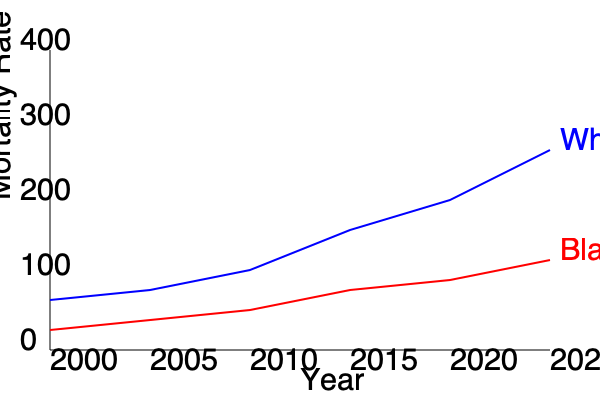Based on the graph showing mortality rates for White and Black populations from 2000 to 2025, what can be concluded about the trend in healthcare disparities between these two groups? How might this trend inform strategies to address healthcare inequities? To interpret the healthcare disparity trends from this multi-line graph and formulate strategies, we need to follow these steps:

1. Analyze the initial disparity:
   - In 2000, the mortality rate for the Black population (about 280 per 100,000) was significantly higher than for the White population (about 250 per 100,000).
   - This indicates a clear health disparity at the beginning of the period.

2. Examine the rate of change for each group:
   - The White population's mortality rate decreases more rapidly, from about 250 to 100 per 100,000 over the 25-year period.
   - The Black population's mortality rate decreases more slowly, from about 280 to 210 per 100,000.

3. Compare the slopes of the lines:
   - The steeper slope for the White population indicates faster improvement in health outcomes.
   - The gentler slope for the Black population suggests slower progress in reducing mortality rates.

4. Assess the gap between the two lines over time:
   - The gap between the two lines widens as time progresses, indicating an increasing disparity.
   - By 2025, the projected gap is larger than it was in 2000, despite overall improvements for both groups.

5. Calculate the relative disparity:
   - In 2000: (280 - 250) / 250 ≈ 12% higher mortality rate for Black population
   - In 2025: (210 - 100) / 100 = 110% higher mortality rate for Black population

6. Interpret the trend:
   - While both populations show improving health outcomes, the rate of improvement is unequal.
   - The disparity is actually worsening over time in relative terms, even as absolute mortality rates decrease for both groups.

7. Implications for healthcare strategies:
   - Need for targeted interventions to accelerate improvements in Black population health outcomes
   - Importance of addressing systemic factors contributing to the widening gap
   - Necessity of monitoring both absolute and relative disparities in health metrics
   - Potential for research into factors driving faster improvements in the White population and how these might be applied more broadly
   - Consideration of social determinants of health that may be impeding progress in the Black population

8. Potential strategies:
   - Increase resource allocation to programs specifically targeting Black community health
   - Enhance cultural competency in healthcare delivery
   - Address socioeconomic factors contributing to health disparities
   - Improve access to quality healthcare in predominantly Black communities
   - Implement policies to reduce systemic racism in healthcare systems
   - Increase representation of Black healthcare professionals and researchers
   - Develop community-based health education and prevention programs
Answer: The trend shows widening healthcare disparities despite overall mortality rate improvements, necessitating targeted interventions to accelerate health outcome improvements for the Black population and address systemic factors contributing to the growing gap. 